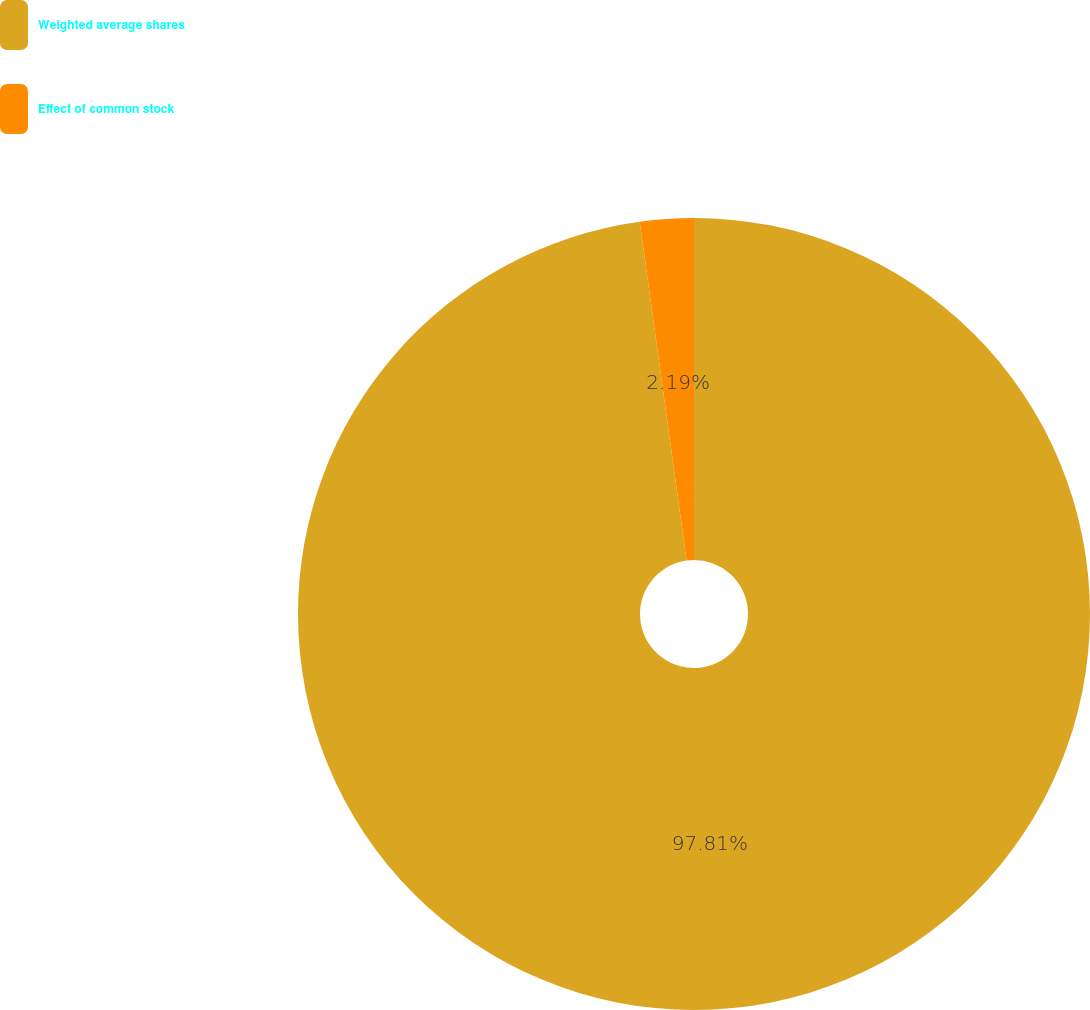Convert chart to OTSL. <chart><loc_0><loc_0><loc_500><loc_500><pie_chart><fcel>Weighted average shares<fcel>Effect of common stock<nl><fcel>97.81%<fcel>2.19%<nl></chart> 